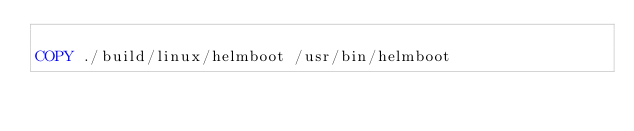<code> <loc_0><loc_0><loc_500><loc_500><_Dockerfile_>
COPY ./build/linux/helmboot /usr/bin/helmboot</code> 